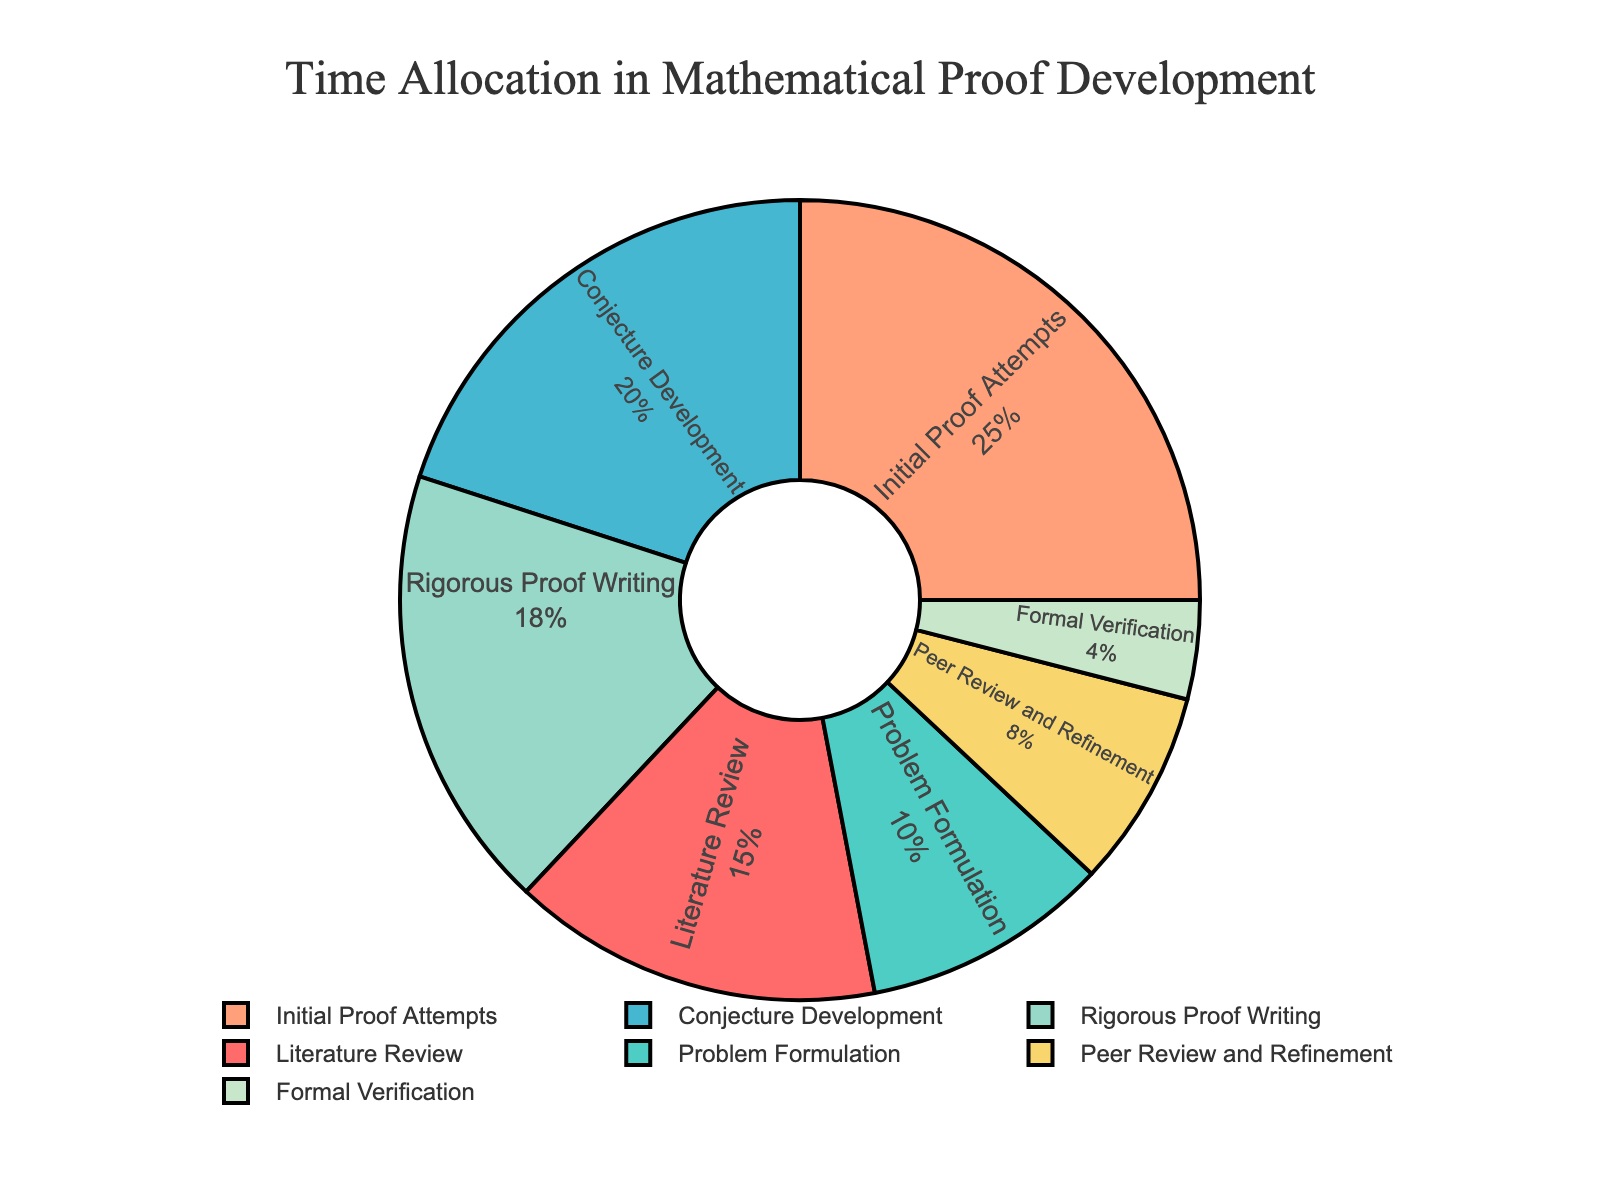What percentage of time is spent on Conjecture Development and Formal Verification combined? To find the combined percentage for Conjecture Development and Formal Verification, add their individual percentages: 20% + 4%.
Answer: 24% How much more time is dedicated to Initial Proof Attempts compared to Peer Review and Refinement? The difference in time allocation between Initial Proof Attempts (25%) and Peer Review and Refinement (8%) is found by subtracting 8% from 25%.
Answer: 17% Which stage uses the least amount of time? By looking at the figure, the stage with the smallest percentage is Formal Verification at 4%.
Answer: Formal Verification Is the time spent on Problem Formulation greater than or less than the time spent on Rigorous Proof Writing? By comparing the percentages, Problem Formulation is allocated 10% while Rigorous Proof Writing is allocated 18%. Thus, time spent on Problem Formulation is less.
Answer: Less What is the total percentage for stages that use up to 20% of the time each? Add the percentages of Literature Review (15%), Problem Formulation (10%), Conjecture Development (20%), Peer Review and Refinement (8%), and Formal Verification (4%). 15% + 10% + 20% + 8% + 4% = 57%.
Answer: 57% Which stage requires the second most amount of time? By examining the figure, the stage with the second highest percentage is Conjecture Development at 20%, second to Initial Proof Attempts.
Answer: Conjecture Development How does the time spent on Literature Review compare to the time spent on Problem Formulation and Peer Review and Refinement combined? Literature Review takes up 15%. Problem Formulation and Peer Review and Refinement combined are 10% + 8% = 18%. Hence, 15% is less than 18%.
Answer: Less What visual attribute helps you quickly identify the stage that occupies the most time? The segments in pie charts are typically largest for stages with the highest percentages. The visual attribute here is the largest segment, which indicates Initial Proof Attempts at 25%.
Answer: Largest segment What fraction of the time is spent on Rigorous Proof Writing relative to the entire proof development process? Rigorous Proof Writing takes up 18%. To find the fraction, 18% of 100% is 18/100, which simplifies to 9/50.
Answer: 9/50 If we combine Literature Review, Problem Formulation, and Formal Verification, what is the average percentage of time spent on these stages? Add the percentages of Literature Review (15%), Problem Formulation (10%), and Formal Verification (4%) and then divide by 3. (15% + 10% + 4%)/3 = 29%/3 ≈ 9.67%.
Answer: 9.67% 